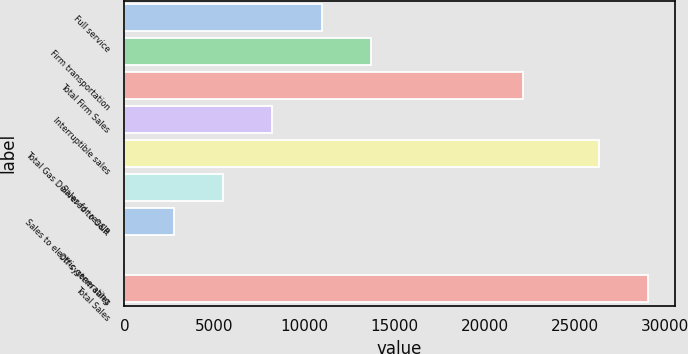<chart> <loc_0><loc_0><loc_500><loc_500><bar_chart><fcel>Full service<fcel>Firm transportation<fcel>Total Firm Sales<fcel>Interruptible sales<fcel>Total Gas Delivered to O&R<fcel>Sales for resale<fcel>Sales to electric generating<fcel>Off-system sales<fcel>Total Sales<nl><fcel>10943.8<fcel>13679<fcel>22121<fcel>8208.6<fcel>26337<fcel>5473.4<fcel>2738.2<fcel>3<fcel>29072.2<nl></chart> 